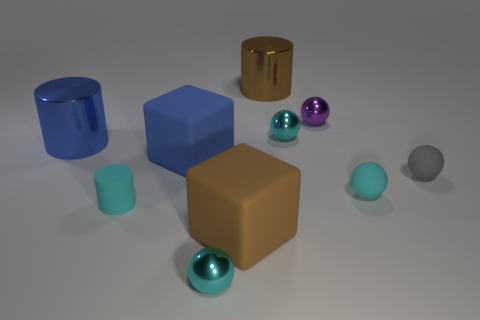Can you describe the differences in texture among the objects shown? Certainly! There is a variety of textures present. The large blue and brown cubes appear to have a matte surface, absorbing light without reflection. The cylinders and spheres, however, have high-gloss finishes that reflect light, bringing out the color and highlights of their surfaces. The contrast in texture adds depth and interest to the scene. 